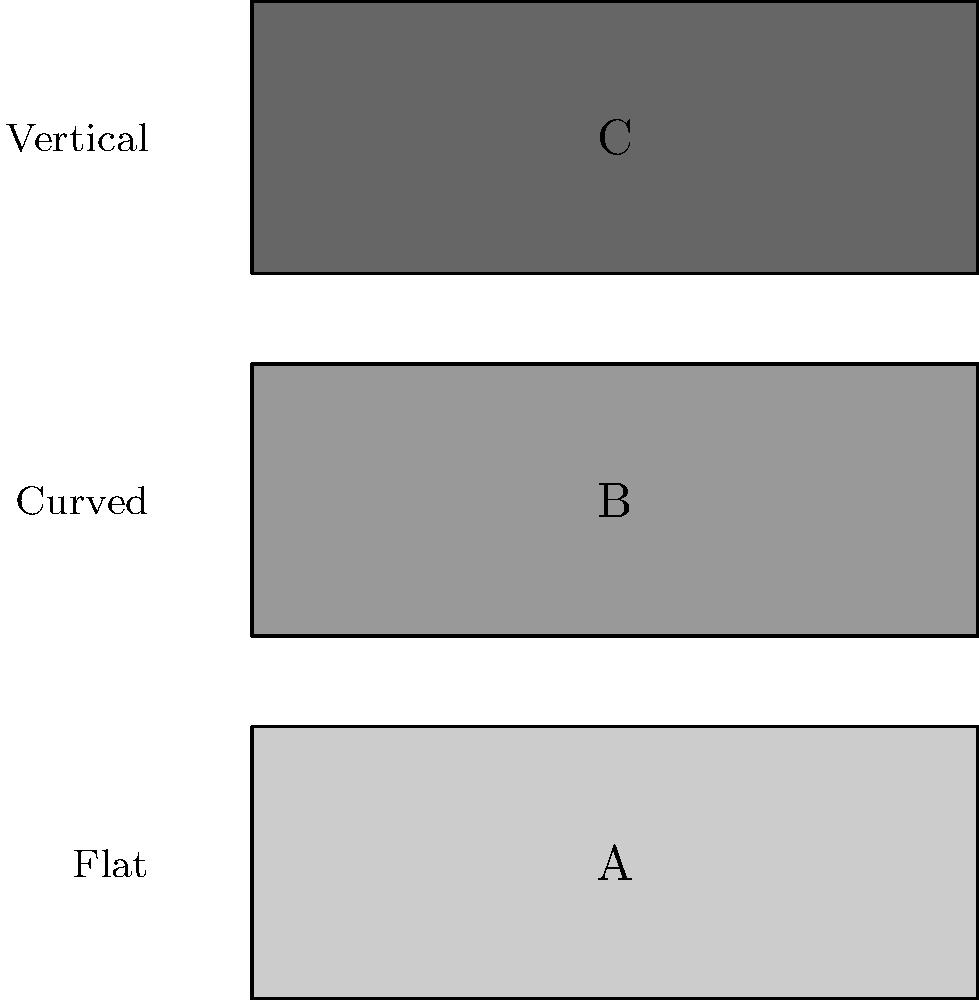Which of the mouse shapes shown in the illustration is most likely to reduce the risk of carpal tunnel syndrome in long-term computer users? To answer this question, we need to consider the principles of ergonomic design and their impact on hand and wrist health:

1. Carpal tunnel syndrome is often caused by repetitive motions and awkward hand positions.

2. The three mouse shapes shown represent:
   A: Flat design
   B: Curved design
   C: Vertical design

3. Ergonomic principles suggest:
   - A neutral wrist position reduces strain on tendons and nerves.
   - Minimizing pronation (rotation) of the forearm reduces stress.

4. Analyzing each design:
   - A (Flat): Requires wrist to lie flat, increasing pronation and potential strain.
   - B (Curved): Provides some support, but still involves significant pronation.
   - C (Vertical): Allows for a more neutral "handshake" position, minimizing pronation.

5. The vertical design (C) most closely mimics the natural resting position of the hand and wrist, reducing the risk of carpal tunnel syndrome.

Therefore, the mouse shape most likely to reduce the risk of carpal tunnel syndrome is the vertical design (C).
Answer: C (Vertical design) 